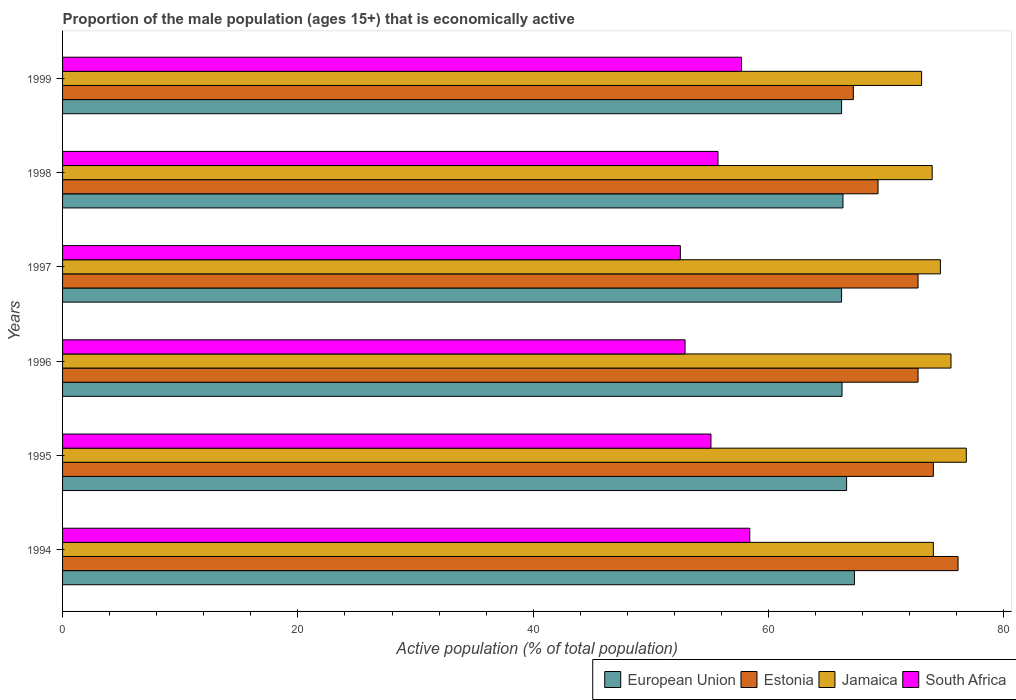How many groups of bars are there?
Give a very brief answer. 6. Are the number of bars per tick equal to the number of legend labels?
Your answer should be very brief. Yes. How many bars are there on the 1st tick from the top?
Your answer should be very brief. 4. How many bars are there on the 3rd tick from the bottom?
Your answer should be compact. 4. What is the proportion of the male population that is economically active in South Africa in 1995?
Your response must be concise. 55.1. Across all years, what is the maximum proportion of the male population that is economically active in Jamaica?
Provide a short and direct response. 76.8. Across all years, what is the minimum proportion of the male population that is economically active in Jamaica?
Keep it short and to the point. 73. In which year was the proportion of the male population that is economically active in Jamaica minimum?
Provide a short and direct response. 1999. What is the total proportion of the male population that is economically active in South Africa in the graph?
Provide a short and direct response. 332.3. What is the difference between the proportion of the male population that is economically active in Estonia in 1996 and that in 1998?
Offer a terse response. 3.4. What is the difference between the proportion of the male population that is economically active in Jamaica in 1995 and the proportion of the male population that is economically active in European Union in 1999?
Keep it short and to the point. 10.6. What is the average proportion of the male population that is economically active in European Union per year?
Ensure brevity in your answer.  66.48. In the year 1995, what is the difference between the proportion of the male population that is economically active in Estonia and proportion of the male population that is economically active in South Africa?
Provide a short and direct response. 18.9. What is the ratio of the proportion of the male population that is economically active in European Union in 1994 to that in 1997?
Provide a short and direct response. 1.02. What is the difference between the highest and the second highest proportion of the male population that is economically active in Estonia?
Your response must be concise. 2.1. What is the difference between the highest and the lowest proportion of the male population that is economically active in Estonia?
Your response must be concise. 8.9. In how many years, is the proportion of the male population that is economically active in European Union greater than the average proportion of the male population that is economically active in European Union taken over all years?
Give a very brief answer. 2. Is it the case that in every year, the sum of the proportion of the male population that is economically active in European Union and proportion of the male population that is economically active in South Africa is greater than the sum of proportion of the male population that is economically active in Jamaica and proportion of the male population that is economically active in Estonia?
Offer a terse response. Yes. What does the 4th bar from the top in 1999 represents?
Your response must be concise. European Union. What does the 3rd bar from the bottom in 1999 represents?
Provide a succinct answer. Jamaica. Is it the case that in every year, the sum of the proportion of the male population that is economically active in Jamaica and proportion of the male population that is economically active in South Africa is greater than the proportion of the male population that is economically active in European Union?
Make the answer very short. Yes. How many years are there in the graph?
Offer a very short reply. 6. Does the graph contain grids?
Ensure brevity in your answer.  No. Where does the legend appear in the graph?
Provide a short and direct response. Bottom right. How many legend labels are there?
Provide a short and direct response. 4. What is the title of the graph?
Offer a terse response. Proportion of the male population (ages 15+) that is economically active. Does "Samoa" appear as one of the legend labels in the graph?
Provide a short and direct response. No. What is the label or title of the X-axis?
Provide a succinct answer. Active population (% of total population). What is the label or title of the Y-axis?
Give a very brief answer. Years. What is the Active population (% of total population) in European Union in 1994?
Your response must be concise. 67.29. What is the Active population (% of total population) of Estonia in 1994?
Your answer should be compact. 76.1. What is the Active population (% of total population) in Jamaica in 1994?
Ensure brevity in your answer.  74. What is the Active population (% of total population) in South Africa in 1994?
Ensure brevity in your answer.  58.4. What is the Active population (% of total population) in European Union in 1995?
Ensure brevity in your answer.  66.63. What is the Active population (% of total population) of Estonia in 1995?
Your response must be concise. 74. What is the Active population (% of total population) in Jamaica in 1995?
Your answer should be compact. 76.8. What is the Active population (% of total population) of South Africa in 1995?
Ensure brevity in your answer.  55.1. What is the Active population (% of total population) in European Union in 1996?
Provide a succinct answer. 66.24. What is the Active population (% of total population) of Estonia in 1996?
Your answer should be compact. 72.7. What is the Active population (% of total population) of Jamaica in 1996?
Provide a short and direct response. 75.5. What is the Active population (% of total population) in South Africa in 1996?
Your answer should be compact. 52.9. What is the Active population (% of total population) of European Union in 1997?
Provide a short and direct response. 66.2. What is the Active population (% of total population) of Estonia in 1997?
Offer a very short reply. 72.7. What is the Active population (% of total population) of Jamaica in 1997?
Provide a short and direct response. 74.6. What is the Active population (% of total population) of South Africa in 1997?
Give a very brief answer. 52.5. What is the Active population (% of total population) of European Union in 1998?
Your answer should be compact. 66.32. What is the Active population (% of total population) of Estonia in 1998?
Provide a short and direct response. 69.3. What is the Active population (% of total population) of Jamaica in 1998?
Your answer should be very brief. 73.9. What is the Active population (% of total population) in South Africa in 1998?
Provide a succinct answer. 55.7. What is the Active population (% of total population) in European Union in 1999?
Provide a short and direct response. 66.2. What is the Active population (% of total population) of Estonia in 1999?
Give a very brief answer. 67.2. What is the Active population (% of total population) in Jamaica in 1999?
Provide a short and direct response. 73. What is the Active population (% of total population) in South Africa in 1999?
Ensure brevity in your answer.  57.7. Across all years, what is the maximum Active population (% of total population) of European Union?
Provide a succinct answer. 67.29. Across all years, what is the maximum Active population (% of total population) in Estonia?
Keep it short and to the point. 76.1. Across all years, what is the maximum Active population (% of total population) in Jamaica?
Ensure brevity in your answer.  76.8. Across all years, what is the maximum Active population (% of total population) of South Africa?
Ensure brevity in your answer.  58.4. Across all years, what is the minimum Active population (% of total population) of European Union?
Give a very brief answer. 66.2. Across all years, what is the minimum Active population (% of total population) of Estonia?
Offer a terse response. 67.2. Across all years, what is the minimum Active population (% of total population) of South Africa?
Your answer should be compact. 52.5. What is the total Active population (% of total population) of European Union in the graph?
Give a very brief answer. 398.88. What is the total Active population (% of total population) of Estonia in the graph?
Give a very brief answer. 432. What is the total Active population (% of total population) in Jamaica in the graph?
Ensure brevity in your answer.  447.8. What is the total Active population (% of total population) in South Africa in the graph?
Your answer should be very brief. 332.3. What is the difference between the Active population (% of total population) in European Union in 1994 and that in 1995?
Make the answer very short. 0.66. What is the difference between the Active population (% of total population) in Estonia in 1994 and that in 1995?
Offer a terse response. 2.1. What is the difference between the Active population (% of total population) of South Africa in 1994 and that in 1995?
Provide a short and direct response. 3.3. What is the difference between the Active population (% of total population) of European Union in 1994 and that in 1996?
Offer a very short reply. 1.05. What is the difference between the Active population (% of total population) of Estonia in 1994 and that in 1996?
Provide a succinct answer. 3.4. What is the difference between the Active population (% of total population) in Jamaica in 1994 and that in 1996?
Keep it short and to the point. -1.5. What is the difference between the Active population (% of total population) of European Union in 1994 and that in 1997?
Keep it short and to the point. 1.09. What is the difference between the Active population (% of total population) of Jamaica in 1994 and that in 1997?
Ensure brevity in your answer.  -0.6. What is the difference between the Active population (% of total population) of European Union in 1994 and that in 1998?
Make the answer very short. 0.97. What is the difference between the Active population (% of total population) of Estonia in 1994 and that in 1998?
Your answer should be very brief. 6.8. What is the difference between the Active population (% of total population) in European Union in 1994 and that in 1999?
Ensure brevity in your answer.  1.09. What is the difference between the Active population (% of total population) of Estonia in 1994 and that in 1999?
Offer a very short reply. 8.9. What is the difference between the Active population (% of total population) of Jamaica in 1994 and that in 1999?
Make the answer very short. 1. What is the difference between the Active population (% of total population) in South Africa in 1994 and that in 1999?
Your response must be concise. 0.7. What is the difference between the Active population (% of total population) of European Union in 1995 and that in 1996?
Make the answer very short. 0.39. What is the difference between the Active population (% of total population) of Jamaica in 1995 and that in 1996?
Ensure brevity in your answer.  1.3. What is the difference between the Active population (% of total population) of European Union in 1995 and that in 1997?
Your response must be concise. 0.43. What is the difference between the Active population (% of total population) in Estonia in 1995 and that in 1997?
Ensure brevity in your answer.  1.3. What is the difference between the Active population (% of total population) in South Africa in 1995 and that in 1997?
Your answer should be compact. 2.6. What is the difference between the Active population (% of total population) of European Union in 1995 and that in 1998?
Your answer should be compact. 0.31. What is the difference between the Active population (% of total population) in South Africa in 1995 and that in 1998?
Your answer should be very brief. -0.6. What is the difference between the Active population (% of total population) of European Union in 1995 and that in 1999?
Your response must be concise. 0.43. What is the difference between the Active population (% of total population) of Estonia in 1995 and that in 1999?
Offer a very short reply. 6.8. What is the difference between the Active population (% of total population) in South Africa in 1995 and that in 1999?
Your response must be concise. -2.6. What is the difference between the Active population (% of total population) in European Union in 1996 and that in 1997?
Offer a terse response. 0.04. What is the difference between the Active population (% of total population) of Jamaica in 1996 and that in 1997?
Your response must be concise. 0.9. What is the difference between the Active population (% of total population) of European Union in 1996 and that in 1998?
Give a very brief answer. -0.08. What is the difference between the Active population (% of total population) of Estonia in 1996 and that in 1998?
Provide a succinct answer. 3.4. What is the difference between the Active population (% of total population) of European Union in 1996 and that in 1999?
Make the answer very short. 0.04. What is the difference between the Active population (% of total population) in Jamaica in 1996 and that in 1999?
Give a very brief answer. 2.5. What is the difference between the Active population (% of total population) in South Africa in 1996 and that in 1999?
Make the answer very short. -4.8. What is the difference between the Active population (% of total population) in European Union in 1997 and that in 1998?
Give a very brief answer. -0.12. What is the difference between the Active population (% of total population) of Jamaica in 1997 and that in 1998?
Give a very brief answer. 0.7. What is the difference between the Active population (% of total population) of Jamaica in 1997 and that in 1999?
Your answer should be compact. 1.6. What is the difference between the Active population (% of total population) in European Union in 1998 and that in 1999?
Offer a very short reply. 0.12. What is the difference between the Active population (% of total population) of Estonia in 1998 and that in 1999?
Your answer should be very brief. 2.1. What is the difference between the Active population (% of total population) in Jamaica in 1998 and that in 1999?
Make the answer very short. 0.9. What is the difference between the Active population (% of total population) of South Africa in 1998 and that in 1999?
Your response must be concise. -2. What is the difference between the Active population (% of total population) in European Union in 1994 and the Active population (% of total population) in Estonia in 1995?
Keep it short and to the point. -6.71. What is the difference between the Active population (% of total population) in European Union in 1994 and the Active population (% of total population) in Jamaica in 1995?
Offer a terse response. -9.51. What is the difference between the Active population (% of total population) in European Union in 1994 and the Active population (% of total population) in South Africa in 1995?
Offer a very short reply. 12.19. What is the difference between the Active population (% of total population) of Estonia in 1994 and the Active population (% of total population) of South Africa in 1995?
Make the answer very short. 21. What is the difference between the Active population (% of total population) in European Union in 1994 and the Active population (% of total population) in Estonia in 1996?
Provide a short and direct response. -5.41. What is the difference between the Active population (% of total population) in European Union in 1994 and the Active population (% of total population) in Jamaica in 1996?
Provide a succinct answer. -8.21. What is the difference between the Active population (% of total population) in European Union in 1994 and the Active population (% of total population) in South Africa in 1996?
Provide a short and direct response. 14.39. What is the difference between the Active population (% of total population) in Estonia in 1994 and the Active population (% of total population) in South Africa in 1996?
Offer a very short reply. 23.2. What is the difference between the Active population (% of total population) of Jamaica in 1994 and the Active population (% of total population) of South Africa in 1996?
Make the answer very short. 21.1. What is the difference between the Active population (% of total population) in European Union in 1994 and the Active population (% of total population) in Estonia in 1997?
Keep it short and to the point. -5.41. What is the difference between the Active population (% of total population) in European Union in 1994 and the Active population (% of total population) in Jamaica in 1997?
Provide a short and direct response. -7.31. What is the difference between the Active population (% of total population) in European Union in 1994 and the Active population (% of total population) in South Africa in 1997?
Your answer should be compact. 14.79. What is the difference between the Active population (% of total population) in Estonia in 1994 and the Active population (% of total population) in Jamaica in 1997?
Offer a terse response. 1.5. What is the difference between the Active population (% of total population) of Estonia in 1994 and the Active population (% of total population) of South Africa in 1997?
Your response must be concise. 23.6. What is the difference between the Active population (% of total population) of European Union in 1994 and the Active population (% of total population) of Estonia in 1998?
Provide a short and direct response. -2.01. What is the difference between the Active population (% of total population) in European Union in 1994 and the Active population (% of total population) in Jamaica in 1998?
Offer a terse response. -6.61. What is the difference between the Active population (% of total population) of European Union in 1994 and the Active population (% of total population) of South Africa in 1998?
Provide a short and direct response. 11.59. What is the difference between the Active population (% of total population) of Estonia in 1994 and the Active population (% of total population) of South Africa in 1998?
Your response must be concise. 20.4. What is the difference between the Active population (% of total population) in Jamaica in 1994 and the Active population (% of total population) in South Africa in 1998?
Offer a very short reply. 18.3. What is the difference between the Active population (% of total population) in European Union in 1994 and the Active population (% of total population) in Estonia in 1999?
Give a very brief answer. 0.09. What is the difference between the Active population (% of total population) of European Union in 1994 and the Active population (% of total population) of Jamaica in 1999?
Offer a very short reply. -5.71. What is the difference between the Active population (% of total population) in European Union in 1994 and the Active population (% of total population) in South Africa in 1999?
Your answer should be very brief. 9.59. What is the difference between the Active population (% of total population) of Estonia in 1994 and the Active population (% of total population) of South Africa in 1999?
Your answer should be compact. 18.4. What is the difference between the Active population (% of total population) of European Union in 1995 and the Active population (% of total population) of Estonia in 1996?
Provide a succinct answer. -6.07. What is the difference between the Active population (% of total population) in European Union in 1995 and the Active population (% of total population) in Jamaica in 1996?
Provide a short and direct response. -8.87. What is the difference between the Active population (% of total population) in European Union in 1995 and the Active population (% of total population) in South Africa in 1996?
Make the answer very short. 13.73. What is the difference between the Active population (% of total population) in Estonia in 1995 and the Active population (% of total population) in South Africa in 1996?
Ensure brevity in your answer.  21.1. What is the difference between the Active population (% of total population) in Jamaica in 1995 and the Active population (% of total population) in South Africa in 1996?
Keep it short and to the point. 23.9. What is the difference between the Active population (% of total population) in European Union in 1995 and the Active population (% of total population) in Estonia in 1997?
Offer a very short reply. -6.07. What is the difference between the Active population (% of total population) in European Union in 1995 and the Active population (% of total population) in Jamaica in 1997?
Provide a short and direct response. -7.97. What is the difference between the Active population (% of total population) of European Union in 1995 and the Active population (% of total population) of South Africa in 1997?
Make the answer very short. 14.13. What is the difference between the Active population (% of total population) in Estonia in 1995 and the Active population (% of total population) in Jamaica in 1997?
Give a very brief answer. -0.6. What is the difference between the Active population (% of total population) of Jamaica in 1995 and the Active population (% of total population) of South Africa in 1997?
Offer a terse response. 24.3. What is the difference between the Active population (% of total population) in European Union in 1995 and the Active population (% of total population) in Estonia in 1998?
Offer a terse response. -2.67. What is the difference between the Active population (% of total population) of European Union in 1995 and the Active population (% of total population) of Jamaica in 1998?
Your answer should be very brief. -7.27. What is the difference between the Active population (% of total population) in European Union in 1995 and the Active population (% of total population) in South Africa in 1998?
Keep it short and to the point. 10.93. What is the difference between the Active population (% of total population) in Estonia in 1995 and the Active population (% of total population) in Jamaica in 1998?
Your answer should be compact. 0.1. What is the difference between the Active population (% of total population) of Jamaica in 1995 and the Active population (% of total population) of South Africa in 1998?
Give a very brief answer. 21.1. What is the difference between the Active population (% of total population) in European Union in 1995 and the Active population (% of total population) in Estonia in 1999?
Keep it short and to the point. -0.57. What is the difference between the Active population (% of total population) in European Union in 1995 and the Active population (% of total population) in Jamaica in 1999?
Your answer should be compact. -6.37. What is the difference between the Active population (% of total population) in European Union in 1995 and the Active population (% of total population) in South Africa in 1999?
Your answer should be compact. 8.93. What is the difference between the Active population (% of total population) in European Union in 1996 and the Active population (% of total population) in Estonia in 1997?
Your answer should be compact. -6.46. What is the difference between the Active population (% of total population) in European Union in 1996 and the Active population (% of total population) in Jamaica in 1997?
Offer a very short reply. -8.36. What is the difference between the Active population (% of total population) in European Union in 1996 and the Active population (% of total population) in South Africa in 1997?
Your answer should be very brief. 13.74. What is the difference between the Active population (% of total population) of Estonia in 1996 and the Active population (% of total population) of South Africa in 1997?
Offer a terse response. 20.2. What is the difference between the Active population (% of total population) of Jamaica in 1996 and the Active population (% of total population) of South Africa in 1997?
Your answer should be compact. 23. What is the difference between the Active population (% of total population) of European Union in 1996 and the Active population (% of total population) of Estonia in 1998?
Keep it short and to the point. -3.06. What is the difference between the Active population (% of total population) of European Union in 1996 and the Active population (% of total population) of Jamaica in 1998?
Provide a short and direct response. -7.66. What is the difference between the Active population (% of total population) of European Union in 1996 and the Active population (% of total population) of South Africa in 1998?
Give a very brief answer. 10.54. What is the difference between the Active population (% of total population) of Jamaica in 1996 and the Active population (% of total population) of South Africa in 1998?
Provide a succinct answer. 19.8. What is the difference between the Active population (% of total population) of European Union in 1996 and the Active population (% of total population) of Estonia in 1999?
Provide a short and direct response. -0.96. What is the difference between the Active population (% of total population) in European Union in 1996 and the Active population (% of total population) in Jamaica in 1999?
Make the answer very short. -6.76. What is the difference between the Active population (% of total population) in European Union in 1996 and the Active population (% of total population) in South Africa in 1999?
Your answer should be compact. 8.54. What is the difference between the Active population (% of total population) of Estonia in 1996 and the Active population (% of total population) of Jamaica in 1999?
Offer a very short reply. -0.3. What is the difference between the Active population (% of total population) in Estonia in 1996 and the Active population (% of total population) in South Africa in 1999?
Your answer should be compact. 15. What is the difference between the Active population (% of total population) in European Union in 1997 and the Active population (% of total population) in Estonia in 1998?
Provide a short and direct response. -3.1. What is the difference between the Active population (% of total population) in European Union in 1997 and the Active population (% of total population) in Jamaica in 1998?
Give a very brief answer. -7.7. What is the difference between the Active population (% of total population) of European Union in 1997 and the Active population (% of total population) of South Africa in 1998?
Your answer should be very brief. 10.5. What is the difference between the Active population (% of total population) in Estonia in 1997 and the Active population (% of total population) in South Africa in 1998?
Offer a very short reply. 17. What is the difference between the Active population (% of total population) of Jamaica in 1997 and the Active population (% of total population) of South Africa in 1998?
Make the answer very short. 18.9. What is the difference between the Active population (% of total population) in European Union in 1997 and the Active population (% of total population) in Estonia in 1999?
Provide a short and direct response. -1. What is the difference between the Active population (% of total population) in European Union in 1997 and the Active population (% of total population) in Jamaica in 1999?
Provide a short and direct response. -6.8. What is the difference between the Active population (% of total population) of European Union in 1997 and the Active population (% of total population) of South Africa in 1999?
Give a very brief answer. 8.5. What is the difference between the Active population (% of total population) in Estonia in 1997 and the Active population (% of total population) in South Africa in 1999?
Keep it short and to the point. 15. What is the difference between the Active population (% of total population) of European Union in 1998 and the Active population (% of total population) of Estonia in 1999?
Keep it short and to the point. -0.88. What is the difference between the Active population (% of total population) of European Union in 1998 and the Active population (% of total population) of Jamaica in 1999?
Offer a terse response. -6.68. What is the difference between the Active population (% of total population) of European Union in 1998 and the Active population (% of total population) of South Africa in 1999?
Your answer should be compact. 8.62. What is the difference between the Active population (% of total population) of Estonia in 1998 and the Active population (% of total population) of Jamaica in 1999?
Make the answer very short. -3.7. What is the difference between the Active population (% of total population) in Estonia in 1998 and the Active population (% of total population) in South Africa in 1999?
Your answer should be compact. 11.6. What is the difference between the Active population (% of total population) in Jamaica in 1998 and the Active population (% of total population) in South Africa in 1999?
Your answer should be very brief. 16.2. What is the average Active population (% of total population) in European Union per year?
Your response must be concise. 66.48. What is the average Active population (% of total population) in Estonia per year?
Your answer should be very brief. 72. What is the average Active population (% of total population) in Jamaica per year?
Ensure brevity in your answer.  74.63. What is the average Active population (% of total population) of South Africa per year?
Offer a terse response. 55.38. In the year 1994, what is the difference between the Active population (% of total population) in European Union and Active population (% of total population) in Estonia?
Your answer should be very brief. -8.81. In the year 1994, what is the difference between the Active population (% of total population) in European Union and Active population (% of total population) in Jamaica?
Give a very brief answer. -6.71. In the year 1994, what is the difference between the Active population (% of total population) of European Union and Active population (% of total population) of South Africa?
Your response must be concise. 8.89. In the year 1995, what is the difference between the Active population (% of total population) in European Union and Active population (% of total population) in Estonia?
Offer a very short reply. -7.37. In the year 1995, what is the difference between the Active population (% of total population) in European Union and Active population (% of total population) in Jamaica?
Offer a terse response. -10.17. In the year 1995, what is the difference between the Active population (% of total population) in European Union and Active population (% of total population) in South Africa?
Give a very brief answer. 11.53. In the year 1995, what is the difference between the Active population (% of total population) of Estonia and Active population (% of total population) of Jamaica?
Keep it short and to the point. -2.8. In the year 1995, what is the difference between the Active population (% of total population) in Estonia and Active population (% of total population) in South Africa?
Provide a short and direct response. 18.9. In the year 1995, what is the difference between the Active population (% of total population) of Jamaica and Active population (% of total population) of South Africa?
Offer a very short reply. 21.7. In the year 1996, what is the difference between the Active population (% of total population) of European Union and Active population (% of total population) of Estonia?
Offer a very short reply. -6.46. In the year 1996, what is the difference between the Active population (% of total population) of European Union and Active population (% of total population) of Jamaica?
Make the answer very short. -9.26. In the year 1996, what is the difference between the Active population (% of total population) of European Union and Active population (% of total population) of South Africa?
Ensure brevity in your answer.  13.34. In the year 1996, what is the difference between the Active population (% of total population) in Estonia and Active population (% of total population) in Jamaica?
Your answer should be very brief. -2.8. In the year 1996, what is the difference between the Active population (% of total population) of Estonia and Active population (% of total population) of South Africa?
Your answer should be compact. 19.8. In the year 1996, what is the difference between the Active population (% of total population) in Jamaica and Active population (% of total population) in South Africa?
Give a very brief answer. 22.6. In the year 1997, what is the difference between the Active population (% of total population) of European Union and Active population (% of total population) of Estonia?
Give a very brief answer. -6.5. In the year 1997, what is the difference between the Active population (% of total population) of European Union and Active population (% of total population) of Jamaica?
Provide a succinct answer. -8.4. In the year 1997, what is the difference between the Active population (% of total population) in European Union and Active population (% of total population) in South Africa?
Your response must be concise. 13.7. In the year 1997, what is the difference between the Active population (% of total population) in Estonia and Active population (% of total population) in Jamaica?
Give a very brief answer. -1.9. In the year 1997, what is the difference between the Active population (% of total population) of Estonia and Active population (% of total population) of South Africa?
Your answer should be very brief. 20.2. In the year 1997, what is the difference between the Active population (% of total population) of Jamaica and Active population (% of total population) of South Africa?
Offer a very short reply. 22.1. In the year 1998, what is the difference between the Active population (% of total population) of European Union and Active population (% of total population) of Estonia?
Provide a short and direct response. -2.98. In the year 1998, what is the difference between the Active population (% of total population) in European Union and Active population (% of total population) in Jamaica?
Provide a succinct answer. -7.58. In the year 1998, what is the difference between the Active population (% of total population) in European Union and Active population (% of total population) in South Africa?
Ensure brevity in your answer.  10.62. In the year 1998, what is the difference between the Active population (% of total population) in Estonia and Active population (% of total population) in South Africa?
Ensure brevity in your answer.  13.6. In the year 1999, what is the difference between the Active population (% of total population) of European Union and Active population (% of total population) of Estonia?
Offer a very short reply. -1. In the year 1999, what is the difference between the Active population (% of total population) in European Union and Active population (% of total population) in Jamaica?
Your answer should be very brief. -6.8. In the year 1999, what is the difference between the Active population (% of total population) in European Union and Active population (% of total population) in South Africa?
Your answer should be very brief. 8.5. In the year 1999, what is the difference between the Active population (% of total population) in Estonia and Active population (% of total population) in South Africa?
Keep it short and to the point. 9.5. In the year 1999, what is the difference between the Active population (% of total population) of Jamaica and Active population (% of total population) of South Africa?
Your response must be concise. 15.3. What is the ratio of the Active population (% of total population) in Estonia in 1994 to that in 1995?
Offer a very short reply. 1.03. What is the ratio of the Active population (% of total population) of Jamaica in 1994 to that in 1995?
Offer a terse response. 0.96. What is the ratio of the Active population (% of total population) of South Africa in 1994 to that in 1995?
Offer a very short reply. 1.06. What is the ratio of the Active population (% of total population) in European Union in 1994 to that in 1996?
Give a very brief answer. 1.02. What is the ratio of the Active population (% of total population) in Estonia in 1994 to that in 1996?
Make the answer very short. 1.05. What is the ratio of the Active population (% of total population) in Jamaica in 1994 to that in 1996?
Your answer should be very brief. 0.98. What is the ratio of the Active population (% of total population) of South Africa in 1994 to that in 1996?
Your response must be concise. 1.1. What is the ratio of the Active population (% of total population) of European Union in 1994 to that in 1997?
Your answer should be compact. 1.02. What is the ratio of the Active population (% of total population) of Estonia in 1994 to that in 1997?
Give a very brief answer. 1.05. What is the ratio of the Active population (% of total population) of Jamaica in 1994 to that in 1997?
Your answer should be very brief. 0.99. What is the ratio of the Active population (% of total population) of South Africa in 1994 to that in 1997?
Keep it short and to the point. 1.11. What is the ratio of the Active population (% of total population) of European Union in 1994 to that in 1998?
Provide a succinct answer. 1.01. What is the ratio of the Active population (% of total population) of Estonia in 1994 to that in 1998?
Ensure brevity in your answer.  1.1. What is the ratio of the Active population (% of total population) of Jamaica in 1994 to that in 1998?
Provide a short and direct response. 1. What is the ratio of the Active population (% of total population) of South Africa in 1994 to that in 1998?
Keep it short and to the point. 1.05. What is the ratio of the Active population (% of total population) in European Union in 1994 to that in 1999?
Your answer should be very brief. 1.02. What is the ratio of the Active population (% of total population) in Estonia in 1994 to that in 1999?
Provide a succinct answer. 1.13. What is the ratio of the Active population (% of total population) in Jamaica in 1994 to that in 1999?
Offer a very short reply. 1.01. What is the ratio of the Active population (% of total population) in South Africa in 1994 to that in 1999?
Your response must be concise. 1.01. What is the ratio of the Active population (% of total population) in European Union in 1995 to that in 1996?
Your answer should be compact. 1.01. What is the ratio of the Active population (% of total population) of Estonia in 1995 to that in 1996?
Provide a short and direct response. 1.02. What is the ratio of the Active population (% of total population) of Jamaica in 1995 to that in 1996?
Offer a terse response. 1.02. What is the ratio of the Active population (% of total population) of South Africa in 1995 to that in 1996?
Give a very brief answer. 1.04. What is the ratio of the Active population (% of total population) of Estonia in 1995 to that in 1997?
Give a very brief answer. 1.02. What is the ratio of the Active population (% of total population) of Jamaica in 1995 to that in 1997?
Your response must be concise. 1.03. What is the ratio of the Active population (% of total population) of South Africa in 1995 to that in 1997?
Ensure brevity in your answer.  1.05. What is the ratio of the Active population (% of total population) of Estonia in 1995 to that in 1998?
Offer a terse response. 1.07. What is the ratio of the Active population (% of total population) of Jamaica in 1995 to that in 1998?
Give a very brief answer. 1.04. What is the ratio of the Active population (% of total population) of European Union in 1995 to that in 1999?
Make the answer very short. 1.01. What is the ratio of the Active population (% of total population) in Estonia in 1995 to that in 1999?
Ensure brevity in your answer.  1.1. What is the ratio of the Active population (% of total population) of Jamaica in 1995 to that in 1999?
Make the answer very short. 1.05. What is the ratio of the Active population (% of total population) of South Africa in 1995 to that in 1999?
Provide a short and direct response. 0.95. What is the ratio of the Active population (% of total population) of European Union in 1996 to that in 1997?
Provide a succinct answer. 1. What is the ratio of the Active population (% of total population) in Estonia in 1996 to that in 1997?
Ensure brevity in your answer.  1. What is the ratio of the Active population (% of total population) of Jamaica in 1996 to that in 1997?
Give a very brief answer. 1.01. What is the ratio of the Active population (% of total population) of South Africa in 1996 to that in 1997?
Make the answer very short. 1.01. What is the ratio of the Active population (% of total population) of Estonia in 1996 to that in 1998?
Make the answer very short. 1.05. What is the ratio of the Active population (% of total population) of Jamaica in 1996 to that in 1998?
Make the answer very short. 1.02. What is the ratio of the Active population (% of total population) in South Africa in 1996 to that in 1998?
Offer a terse response. 0.95. What is the ratio of the Active population (% of total population) of Estonia in 1996 to that in 1999?
Keep it short and to the point. 1.08. What is the ratio of the Active population (% of total population) in Jamaica in 1996 to that in 1999?
Give a very brief answer. 1.03. What is the ratio of the Active population (% of total population) of South Africa in 1996 to that in 1999?
Make the answer very short. 0.92. What is the ratio of the Active population (% of total population) in European Union in 1997 to that in 1998?
Your answer should be very brief. 1. What is the ratio of the Active population (% of total population) of Estonia in 1997 to that in 1998?
Offer a very short reply. 1.05. What is the ratio of the Active population (% of total population) in Jamaica in 1997 to that in 1998?
Make the answer very short. 1.01. What is the ratio of the Active population (% of total population) of South Africa in 1997 to that in 1998?
Offer a terse response. 0.94. What is the ratio of the Active population (% of total population) of Estonia in 1997 to that in 1999?
Keep it short and to the point. 1.08. What is the ratio of the Active population (% of total population) of Jamaica in 1997 to that in 1999?
Keep it short and to the point. 1.02. What is the ratio of the Active population (% of total population) of South Africa in 1997 to that in 1999?
Ensure brevity in your answer.  0.91. What is the ratio of the Active population (% of total population) in European Union in 1998 to that in 1999?
Offer a terse response. 1. What is the ratio of the Active population (% of total population) in Estonia in 1998 to that in 1999?
Keep it short and to the point. 1.03. What is the ratio of the Active population (% of total population) in Jamaica in 1998 to that in 1999?
Provide a short and direct response. 1.01. What is the ratio of the Active population (% of total population) in South Africa in 1998 to that in 1999?
Keep it short and to the point. 0.97. What is the difference between the highest and the second highest Active population (% of total population) of European Union?
Make the answer very short. 0.66. What is the difference between the highest and the second highest Active population (% of total population) in Jamaica?
Offer a very short reply. 1.3. What is the difference between the highest and the second highest Active population (% of total population) of South Africa?
Your answer should be compact. 0.7. What is the difference between the highest and the lowest Active population (% of total population) in European Union?
Make the answer very short. 1.09. What is the difference between the highest and the lowest Active population (% of total population) in Estonia?
Provide a succinct answer. 8.9. What is the difference between the highest and the lowest Active population (% of total population) of Jamaica?
Offer a terse response. 3.8. What is the difference between the highest and the lowest Active population (% of total population) of South Africa?
Give a very brief answer. 5.9. 